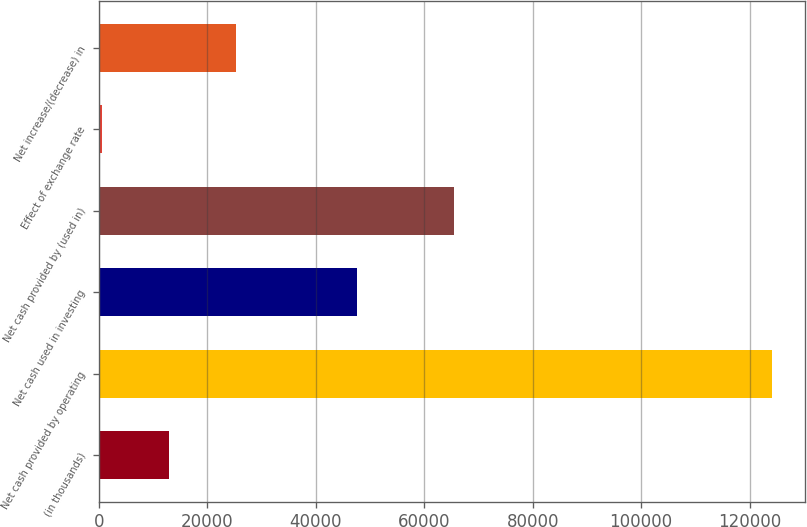Convert chart. <chart><loc_0><loc_0><loc_500><loc_500><bar_chart><fcel>(in thousands)<fcel>Net cash provided by operating<fcel>Net cash used in investing<fcel>Net cash provided by (used in)<fcel>Effect of exchange rate<fcel>Net increase/(decrease) in<nl><fcel>12853.5<fcel>124053<fcel>47645<fcel>65497<fcel>498<fcel>25209<nl></chart> 